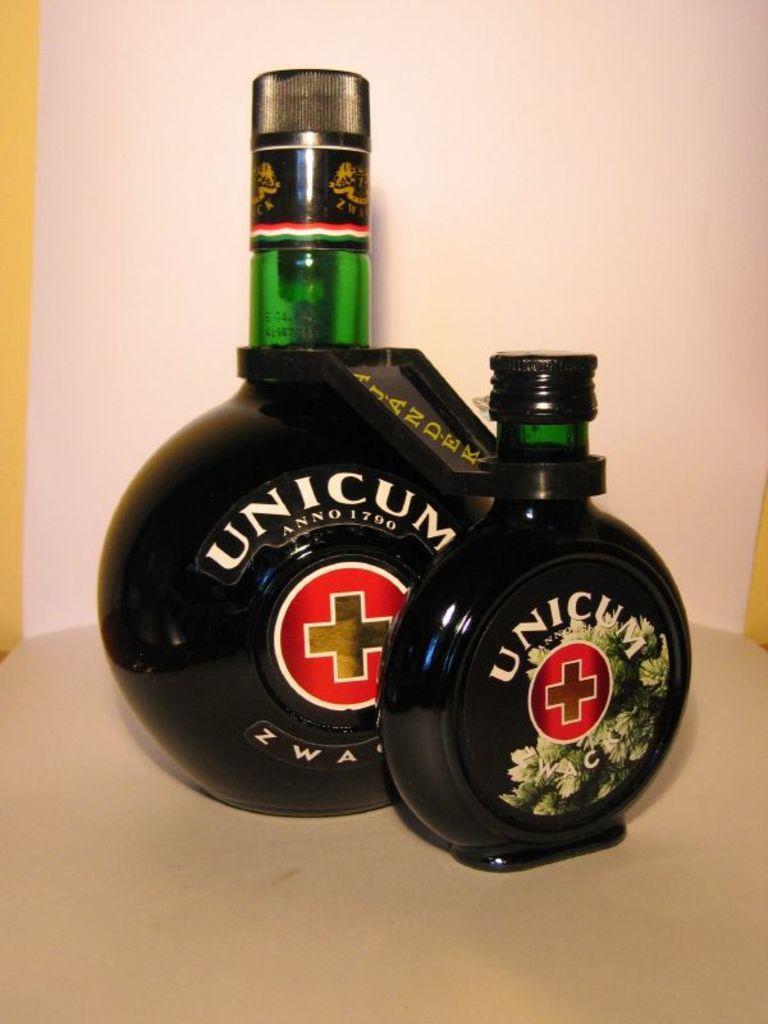When was the company founded?
Keep it short and to the point. 1790. 